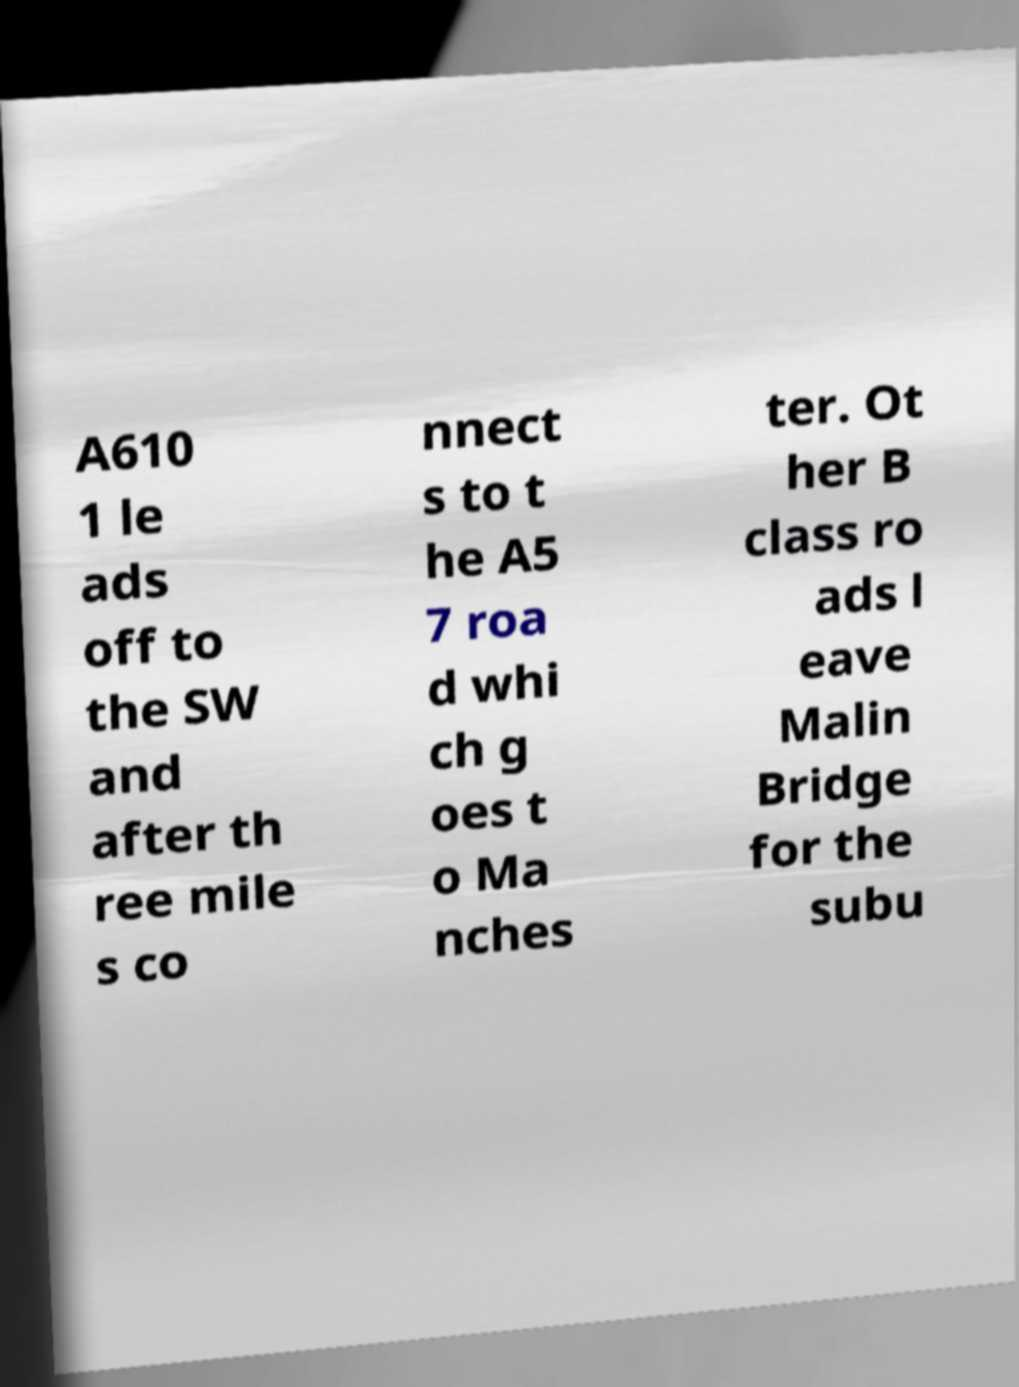Could you assist in decoding the text presented in this image and type it out clearly? A610 1 le ads off to the SW and after th ree mile s co nnect s to t he A5 7 roa d whi ch g oes t o Ma nches ter. Ot her B class ro ads l eave Malin Bridge for the subu 